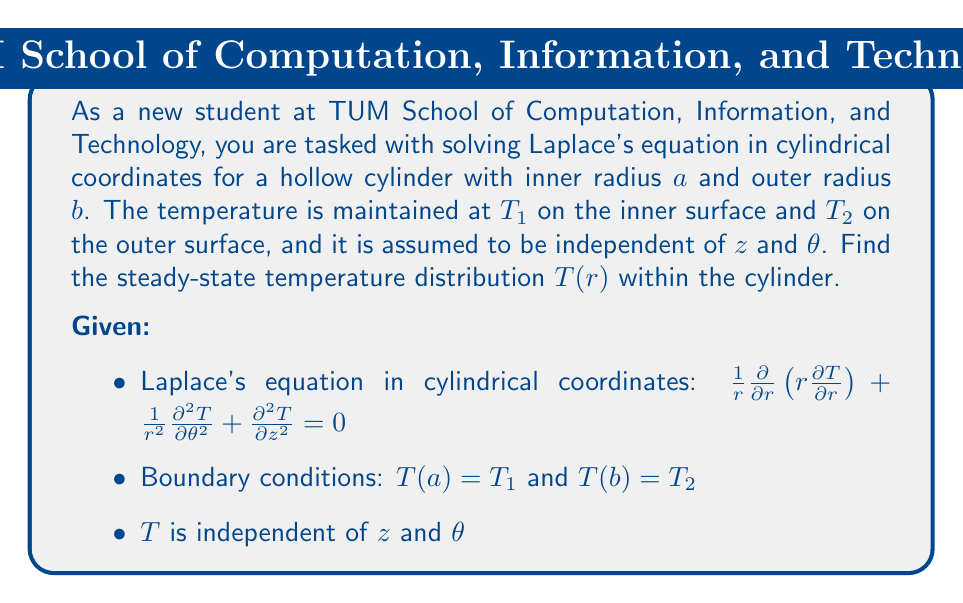Help me with this question. Let's solve this problem step by step using the separation of variables method:

1) Since $T$ is independent of $z$ and $\theta$, Laplace's equation reduces to:

   $$\frac{1}{r}\frac{d}{dr}\left(r\frac{dT}{dr}\right) = 0$$

2) Multiply both sides by $r$:

   $$\frac{d}{dr}\left(r\frac{dT}{dr}\right) = 0$$

3) Integrate both sides with respect to $r$:

   $$r\frac{dT}{dr} = C_1$$

   where $C_1$ is a constant of integration.

4) Divide both sides by $r$ and integrate again:

   $$\int \frac{1}{r} \frac{dT}{dr} dr = \int \frac{C_1}{r} dr$$

   $$T = C_1 \ln(r) + C_2$$

   where $C_2$ is another constant of integration.

5) Now, apply the boundary conditions:

   At $r = a$: $T_1 = C_1 \ln(a) + C_2$
   At $r = b$: $T_2 = C_1 \ln(b) + C_2$

6) Subtract these equations:

   $$T_2 - T_1 = C_1 (\ln(b) - \ln(a)) = C_1 \ln(b/a)$$

7) Solve for $C_1$:

   $$C_1 = \frac{T_2 - T_1}{\ln(b/a)}$$

8) Substitute this back into the equation from step 4:

   $$T = \frac{T_2 - T_1}{\ln(b/a)} \ln(r) + C_2$$

9) Use the boundary condition at $r = a$ to find $C_2$:

   $$T_1 = \frac{T_2 - T_1}{\ln(b/a)} \ln(a) + C_2$$

   $$C_2 = T_1 - \frac{T_2 - T_1}{\ln(b/a)} \ln(a)$$

10) The final solution is:

    $$T(r) = \frac{T_2 - T_1}{\ln(b/a)} \ln(r) + T_1 - \frac{T_2 - T_1}{\ln(b/a)} \ln(a)$$

This can be simplified to:

$$T(r) = T_1 + (T_2 - T_1) \frac{\ln(r/a)}{\ln(b/a)}$$
Answer: The steady-state temperature distribution within the hollow cylinder is:

$$T(r) = T_1 + (T_2 - T_1) \frac{\ln(r/a)}{\ln(b/a)}$$

where $a \leq r \leq b$, $T_1$ is the temperature at the inner surface $(r = a)$, and $T_2$ is the temperature at the outer surface $(r = b)$. 